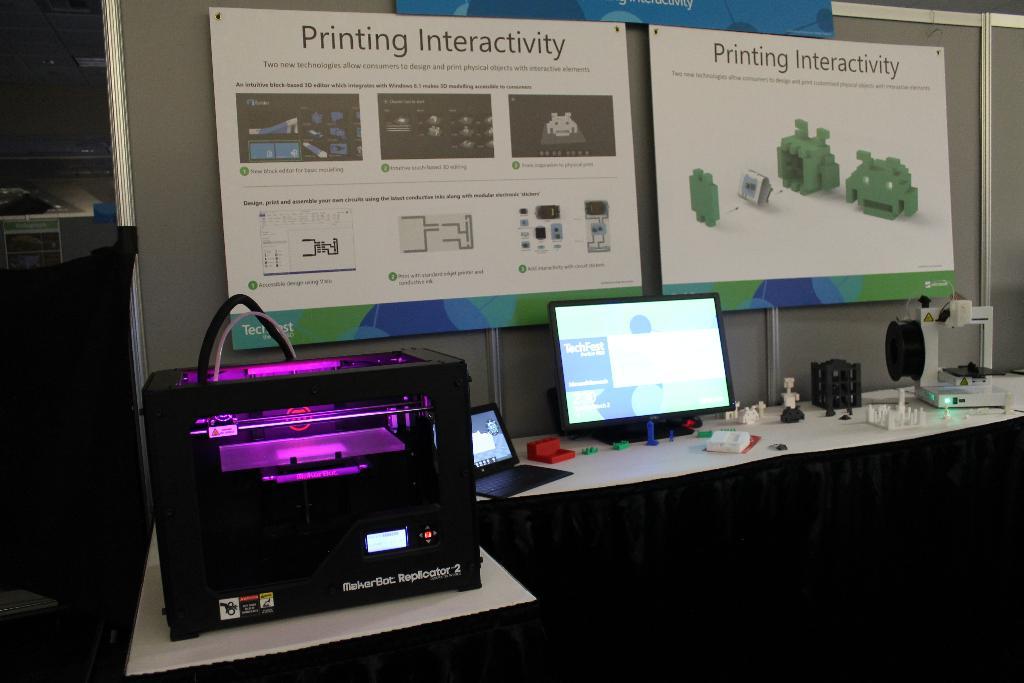What is the subject of the two large signs on the wall?
Your answer should be very brief. Printing interactivity. What is the top thing written on both posters?
Offer a very short reply. Printing interactivity. 